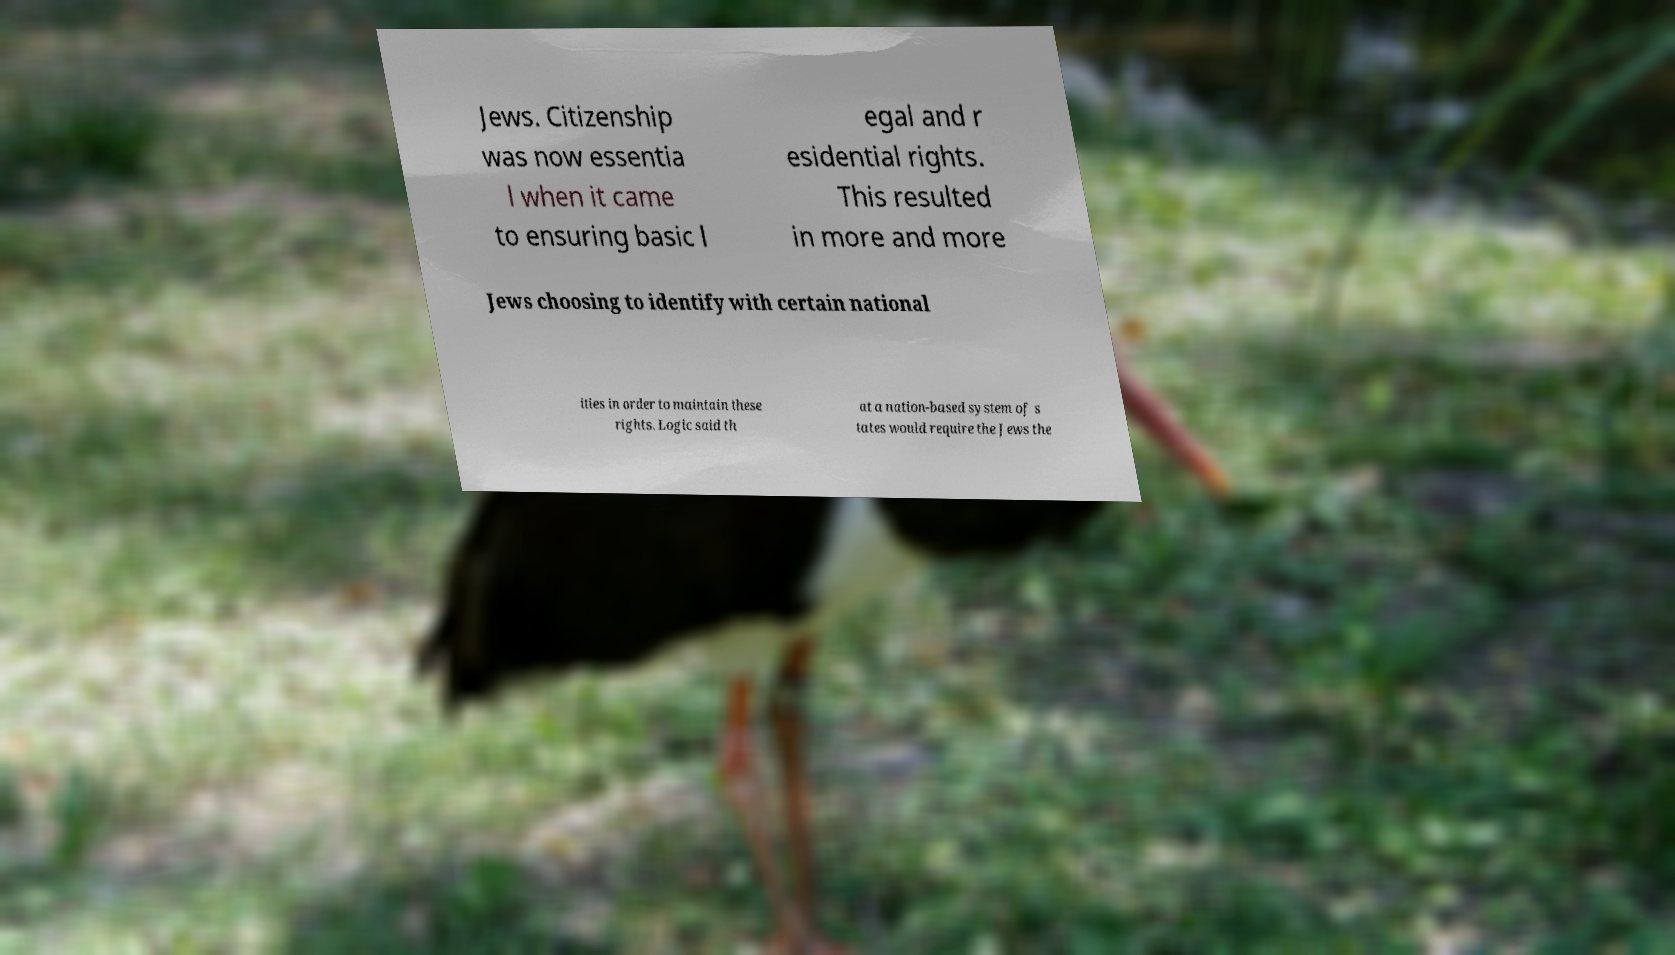Can you accurately transcribe the text from the provided image for me? Jews. Citizenship was now essentia l when it came to ensuring basic l egal and r esidential rights. This resulted in more and more Jews choosing to identify with certain national ities in order to maintain these rights. Logic said th at a nation-based system of s tates would require the Jews the 